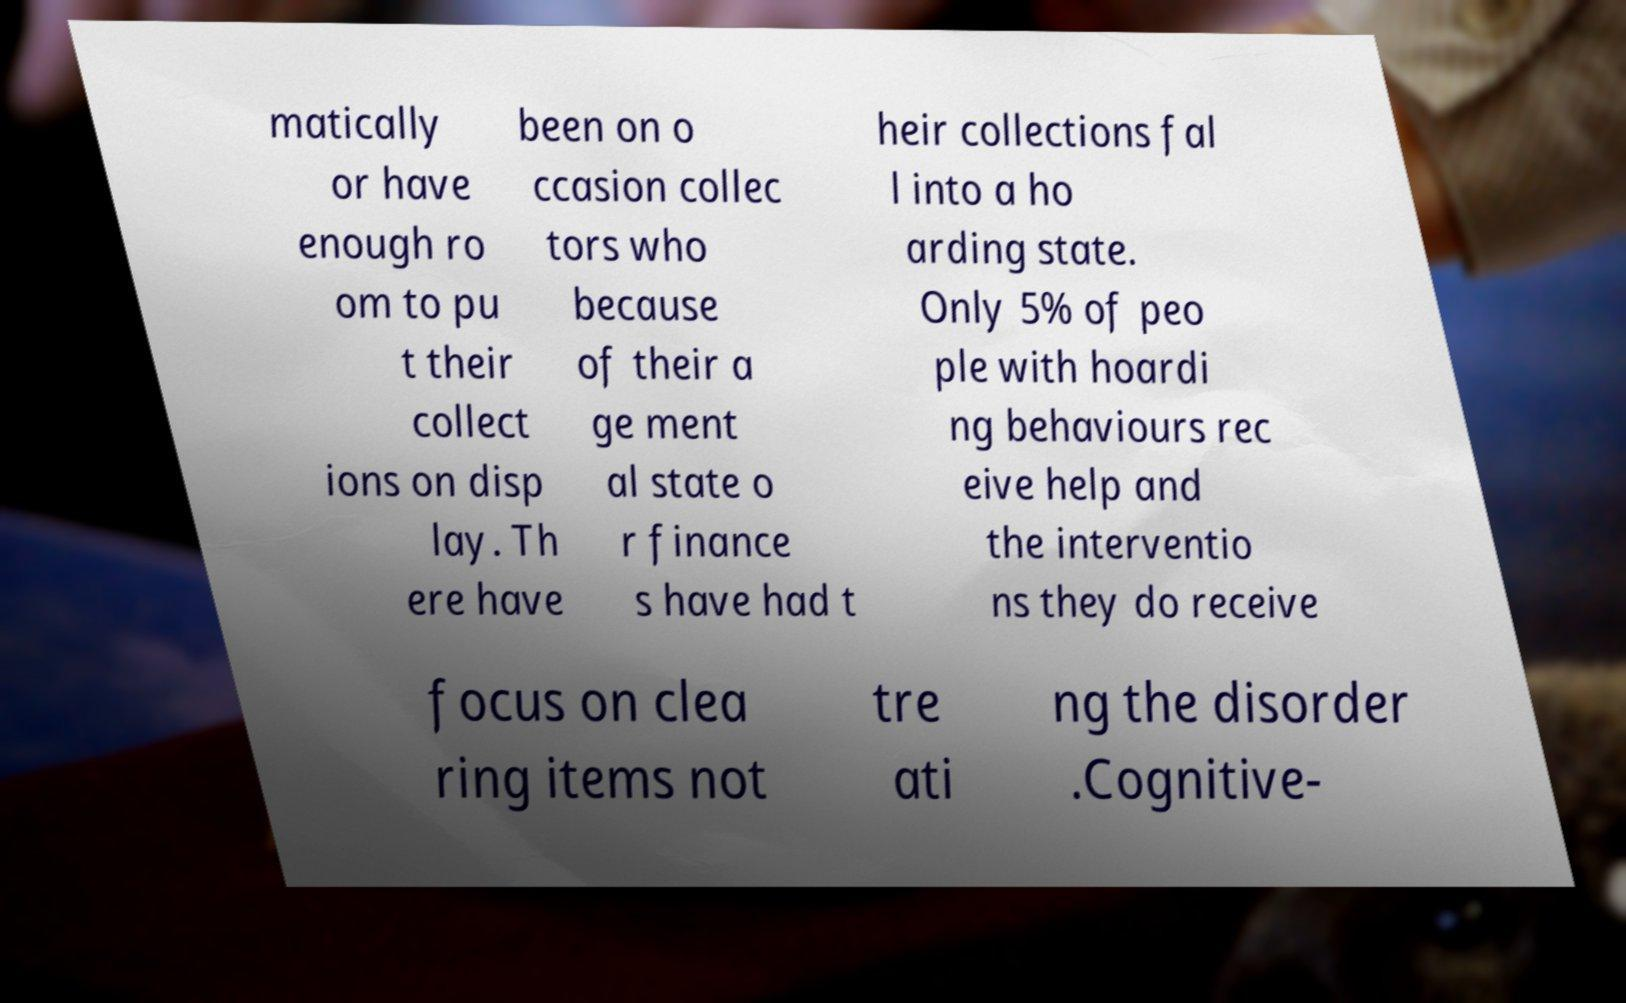Please read and relay the text visible in this image. What does it say? matically or have enough ro om to pu t their collect ions on disp lay. Th ere have been on o ccasion collec tors who because of their a ge ment al state o r finance s have had t heir collections fal l into a ho arding state. Only 5% of peo ple with hoardi ng behaviours rec eive help and the interventio ns they do receive focus on clea ring items not tre ati ng the disorder .Cognitive- 